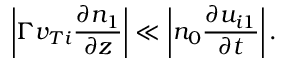<formula> <loc_0><loc_0><loc_500><loc_500>\left | \Gamma v _ { T i } \frac { \partial n _ { 1 } } { \partial z } \right | \ll \left | n _ { 0 } \frac { \partial u _ { i 1 } } { \partial t } \right | .</formula> 